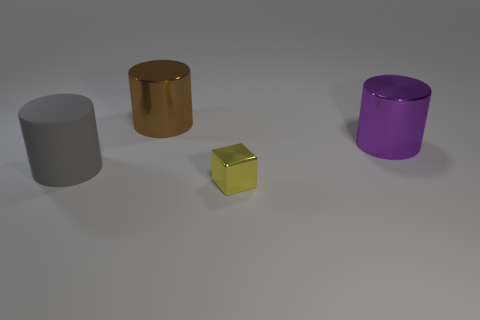Is the matte thing the same color as the tiny cube?
Provide a short and direct response. No. Is there anything else of the same color as the matte object?
Offer a terse response. No. How many big shiny cylinders are left of the big metal cylinder that is in front of the shiny object on the left side of the yellow block?
Provide a short and direct response. 1. Are there fewer big purple cylinders than big blue shiny spheres?
Offer a terse response. No. There is a metal thing that is left of the block; is its shape the same as the metal object that is in front of the purple cylinder?
Provide a succinct answer. No. What is the color of the large rubber object?
Give a very brief answer. Gray. What number of matte objects are gray things or small blue cylinders?
Your answer should be compact. 1. What is the color of the other shiny thing that is the same shape as the large brown metallic object?
Keep it short and to the point. Purple. Are there any large brown things?
Ensure brevity in your answer.  Yes. Are the cylinder in front of the big purple metallic cylinder and the big object that is behind the purple thing made of the same material?
Your answer should be compact. No. 